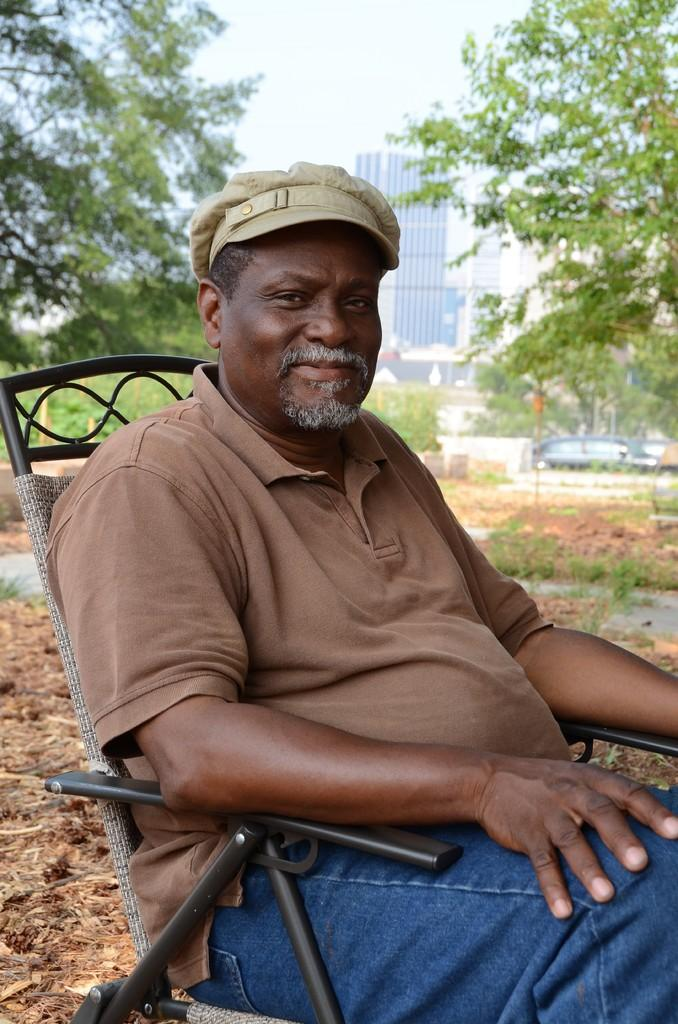What type of structures can be seen in the image? There are buildings in the image. What other natural elements are present in the image? There are trees in the image. Can you describe the man's appearance in the image? The man is seated on a chair and is wearing a cap. How would you describe the weather in the image? The sky is cloudy in the image. What language is the man speaking in the image? There is no indication of the man speaking in the image, nor is there any information about the language he might be speaking. Can you see any marks or symbols on the trees in the image? There is no mention of marks or symbols on the trees in the image; only the presence of trees is noted. 